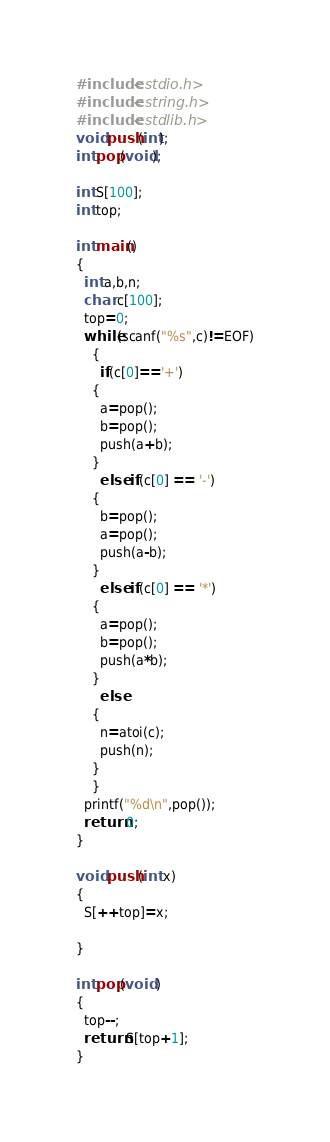Convert code to text. <code><loc_0><loc_0><loc_500><loc_500><_C_>#include<stdio.h>
#include<string.h>
#include<stdlib.h>
void push(int);
int pop(void);
 
int S[100];
int top;
 
int main()
{
  int a,b,n;
  char c[100];
  top=0;
  while(scanf("%s",c)!=EOF)
    {
      if(c[0]=='+')
    {
      a=pop();
      b=pop();
      push(a+b);
    }
      else if(c[0] == '-')
    {
      b=pop();
      a=pop();
      push(a-b);
    }
      else if(c[0] == '*')
    {
      a=pop();
      b=pop();
      push(a*b);
    }
      else
    {
      n=atoi(c);
      push(n);
    }
    }
  printf("%d\n",pop());
  return 0;
}
 
void push(int x)
{
  S[++top]=x;
 
}
 
int pop(void )
{
  top--;
  return S[top+1];
}</code> 